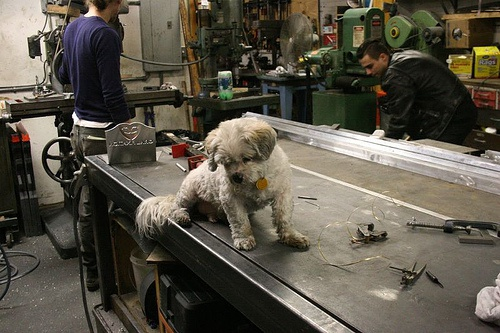Describe the objects in this image and their specific colors. I can see dog in darkgray, black, and gray tones, people in darkgray, black, gray, and maroon tones, and people in darkgray, black, maroon, and gray tones in this image. 